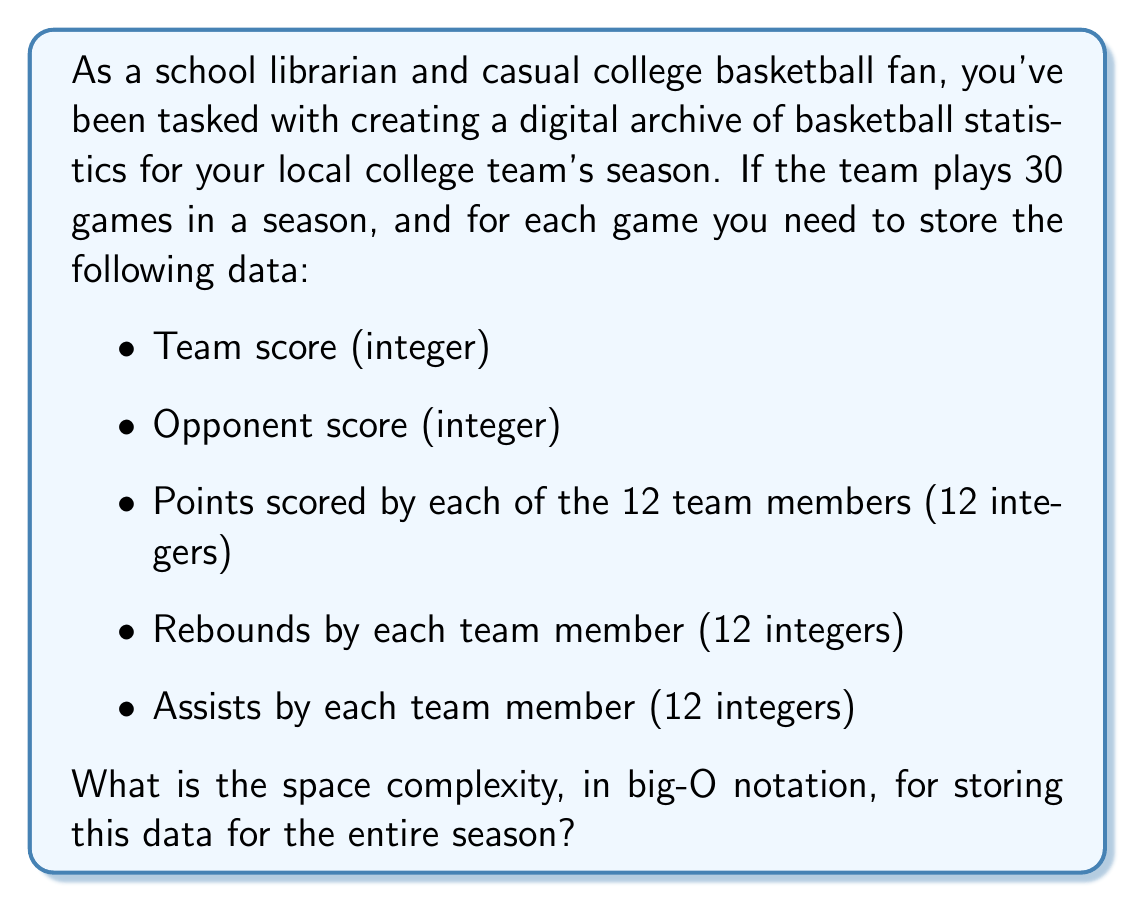Can you answer this question? Let's break this down step-by-step:

1. For each game, we need to store:
   - 2 integers for team and opponent scores
   - 12 integers for points scored by each team member
   - 12 integers for rebounds by each team member
   - 12 integers for assists by each team member

2. Total integers per game:
   $2 + 12 + 12 + 12 = 38$ integers

3. Assuming each integer takes a constant amount of space (let's call it $c$), the space required for one game is $38c$.

4. For the entire season of 30 games, the total space required is:
   $30 \times 38c = 1140c$

5. In big-O notation, we ignore constant factors. Therefore, the space complexity is $O(1)$, as it's a constant amount of space regardless of input size.

However, if we consider the number of games ($n$) as a variable input:

6. The space required would be $38cn$, which simplifies to $O(n)$ in big-O notation.

In this case, the space complexity grows linearly with the number of games.
Answer: $O(n)$, where $n$ is the number of games in the season. 